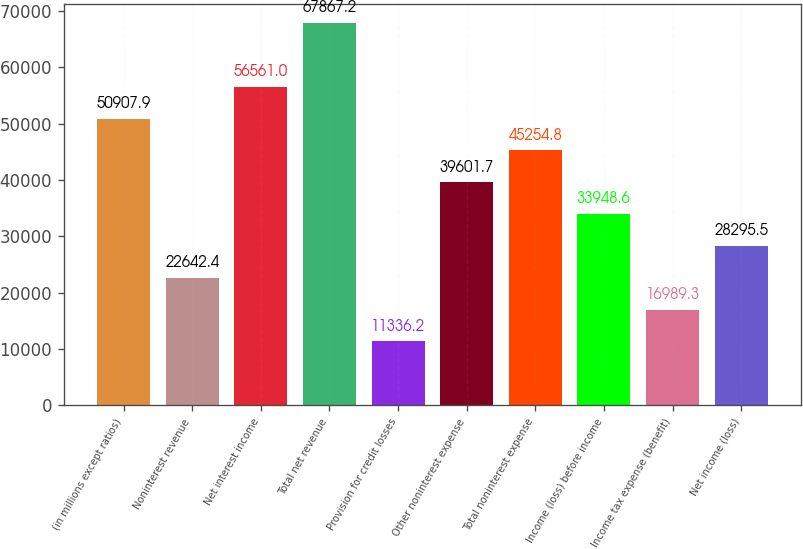Convert chart. <chart><loc_0><loc_0><loc_500><loc_500><bar_chart><fcel>(in millions except ratios)<fcel>Noninterest revenue<fcel>Net interest income<fcel>Total net revenue<fcel>Provision for credit losses<fcel>Other noninterest expense<fcel>Total noninterest expense<fcel>Income (loss) before income<fcel>Income tax expense (benefit)<fcel>Net income (loss)<nl><fcel>50907.9<fcel>22642.4<fcel>56561<fcel>67867.2<fcel>11336.2<fcel>39601.7<fcel>45254.8<fcel>33948.6<fcel>16989.3<fcel>28295.5<nl></chart> 